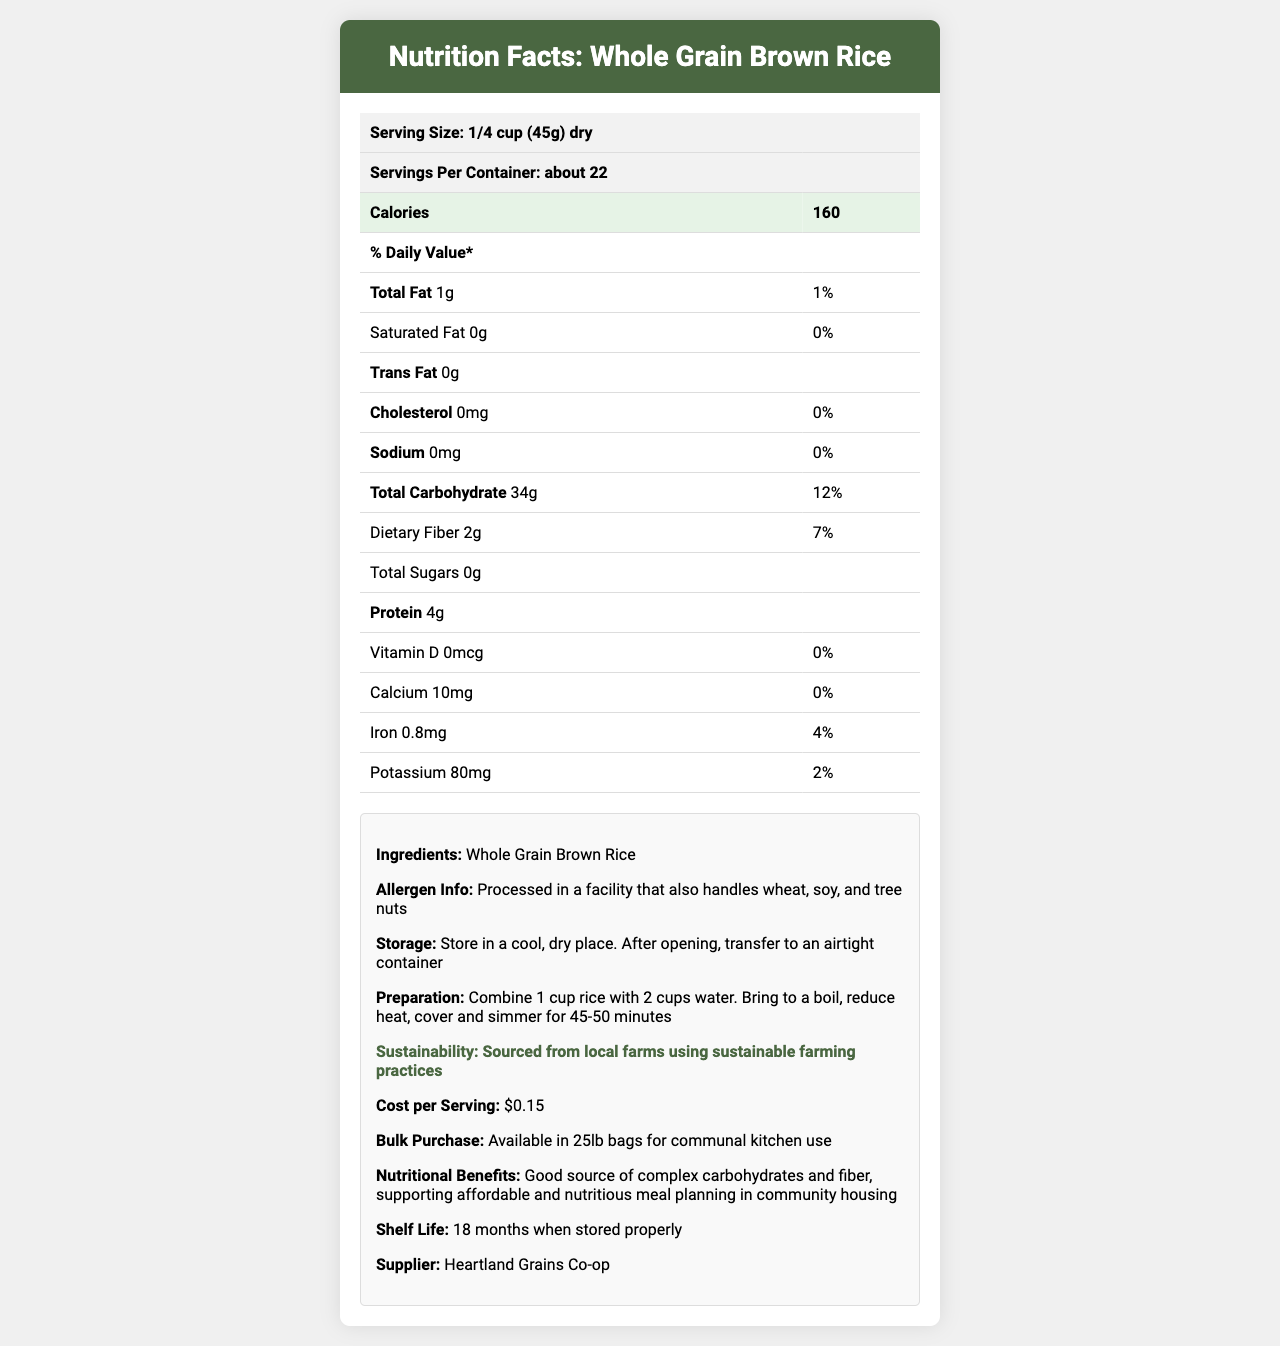what is the product name? The product name is prominently displayed at the top of the document in the header section.
Answer: Whole Grain Brown Rice what is the serving size? The serving size is listed near the top of the document under the product name.
Answer: 1/4 cup (45g) dry how many servings are there per container? The number of servings per container is provided directly below the serving size.
Answer: About 22 how many calories are there per serving? The number of calories per serving is highlighted in a row with a larger font.
Answer: 160 calories how much is the cost per serving? The cost per serving is listed in the "info-box" section under "Cost per Serving."
Answer: $0.15 What are the total carbohydrates per serving? A. 12g B. 20g C. 34g D. 40g The total carbohydrates per serving is mentioned as 34g in the "Total Carbohydrate" row within the nutrition facts table.
Answer: C Which of the following vitamins or minerals has the highest daily value percentage per serving? I. Calcium II. Iron III. Vitamin D IV. Potassium Iron has the highest daily value percentage (4%) per serving compared to Calcium (0%), Vitamin D (0%), and Potassium (2%).
Answer: II Is there any trans fat in this product? The document clearly states "Trans Fat 0g," indicating there is no trans fat.
Answer: No Summarize the main idea of this document. The document provides a comprehensive overview of Whole Grain Brown Rice. It details the nutritional content per serving, health benefits, storage, and preparation instructions, and emphasizes its affordability and sustainability. It is designed for use in communal cooking spaces within affordable housing developments.
Answer: This document provides detailed nutritional information about Whole Grain Brown Rice, including serving size, calories, macronutrients, vitamins, minerals, ingredients, allergen information, storage and preparation instructions, sustainability practices, cost and bulk purchase information, and the supplier details. Are there any added sugars in this product? The document states "Total Sugars 0g," which means there are no added sugars in the product.
Answer: No What is the shelf life of this product if stored properly? The shelf life mentioned in the "info-box" section is 18 months when stored properly.
Answer: 18 months What are the ingredients listed for the product? The ingredient list in the info-box section states that the only ingredient is "Whole Grain Brown Rice."
Answer: Whole Grain Brown Rice Can this product be considered a good source of protein? With only 4g of protein per serving, this product is not typically considered a good source of protein compared to foods higher in protein content.
Answer: No How much iron is present in each serving, and what is its daily value percentage? The iron content per serving is listed as 0.8mg, and the daily value percentage is 4%.
Answer: 0.8mg, 4% What are the potential allergens mentioned in the document? The allergen information section indicates that the product is processed in a facility that handles wheat, soy, and tree nuts.
Answer: Wheat, soy, and tree nuts Does the preparation of this rice require boiling the water first? The preparation instructions specify to bring the water to a boil before reducing the heat, covering, and simmering.
Answer: Yes What sustainable practice is mentioned for sourcing this product? The sustainability info mentions that the product is sourced from local farms that use sustainable farming practices.
Answer: Sourced from local farms using sustainable farming practices Who is the supplier of this product? The supplier information at the end of the document specifies Heartland Grains Co-op as the supplier.
Answer: Heartland Grains Co-op Is there any information provided about the packaging of this product? The document does not state specific details about the product packaging beyond storage instructions.
Answer: Not enough information What is the amount of unsaturated fat per serving? The document does not specify the amount of unsaturated fat per serving.
Answer: Not provided 